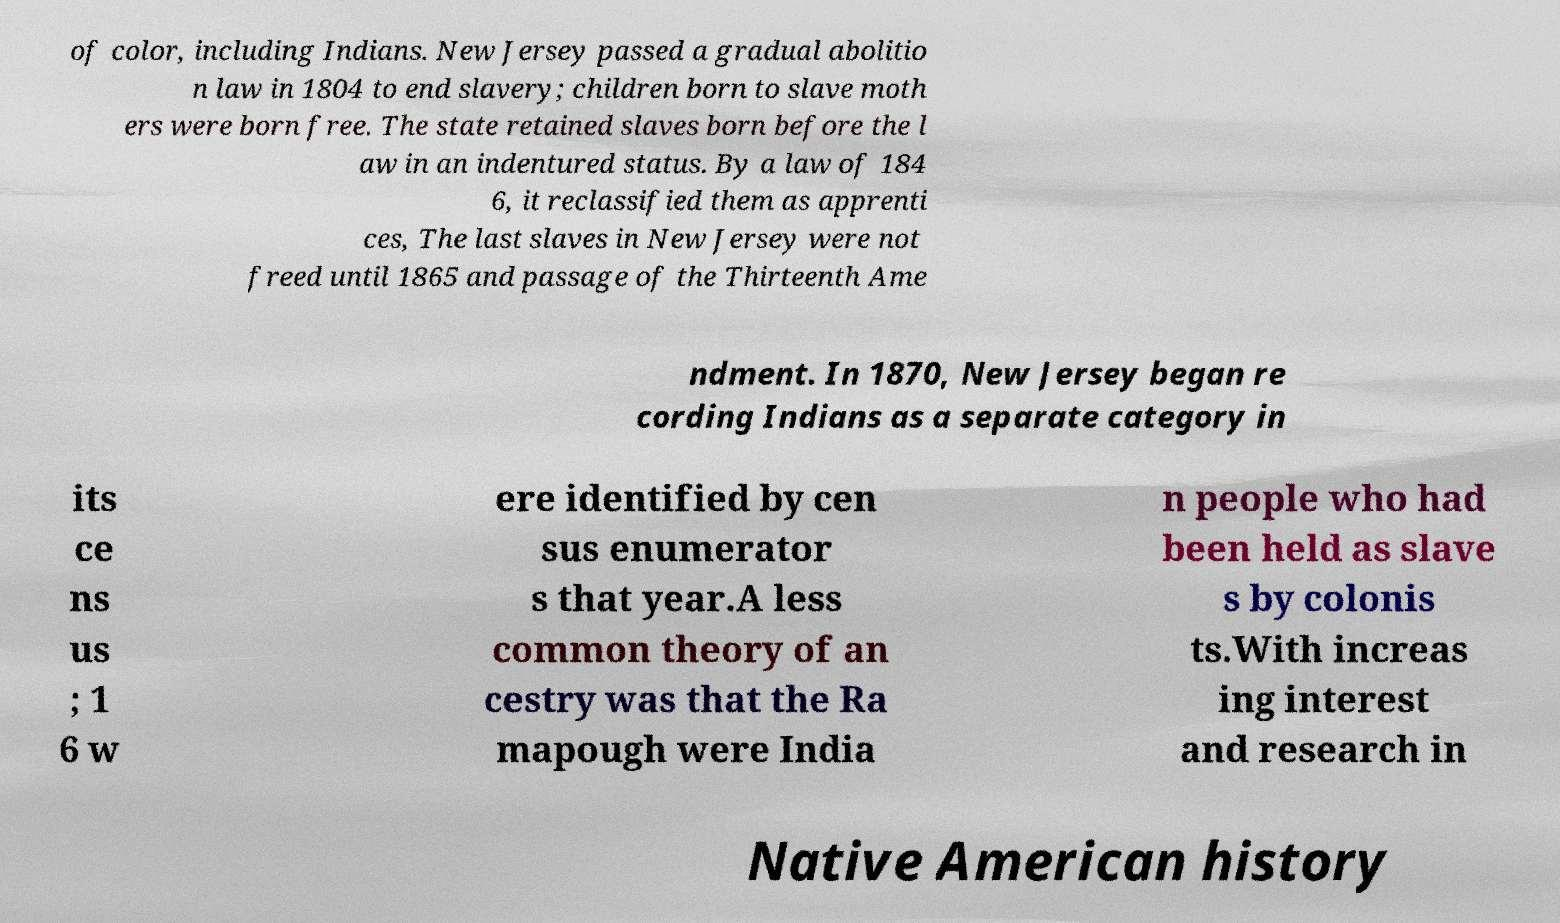There's text embedded in this image that I need extracted. Can you transcribe it verbatim? of color, including Indians. New Jersey passed a gradual abolitio n law in 1804 to end slavery; children born to slave moth ers were born free. The state retained slaves born before the l aw in an indentured status. By a law of 184 6, it reclassified them as apprenti ces, The last slaves in New Jersey were not freed until 1865 and passage of the Thirteenth Ame ndment. In 1870, New Jersey began re cording Indians as a separate category in its ce ns us ; 1 6 w ere identified by cen sus enumerator s that year.A less common theory of an cestry was that the Ra mapough were India n people who had been held as slave s by colonis ts.With increas ing interest and research in Native American history 